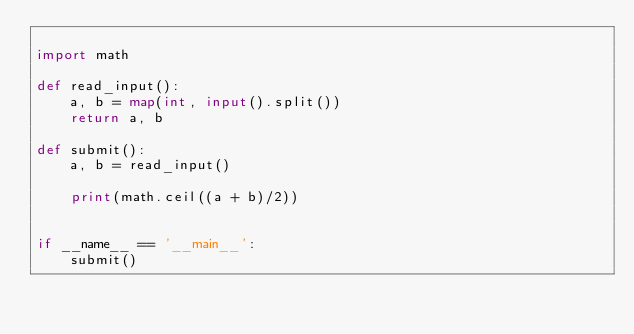<code> <loc_0><loc_0><loc_500><loc_500><_Python_>
import math

def read_input():
    a, b = map(int, input().split())
    return a, b

def submit():
    a, b = read_input()

    print(math.ceil((a + b)/2))


if __name__ == '__main__':
    submit()</code> 